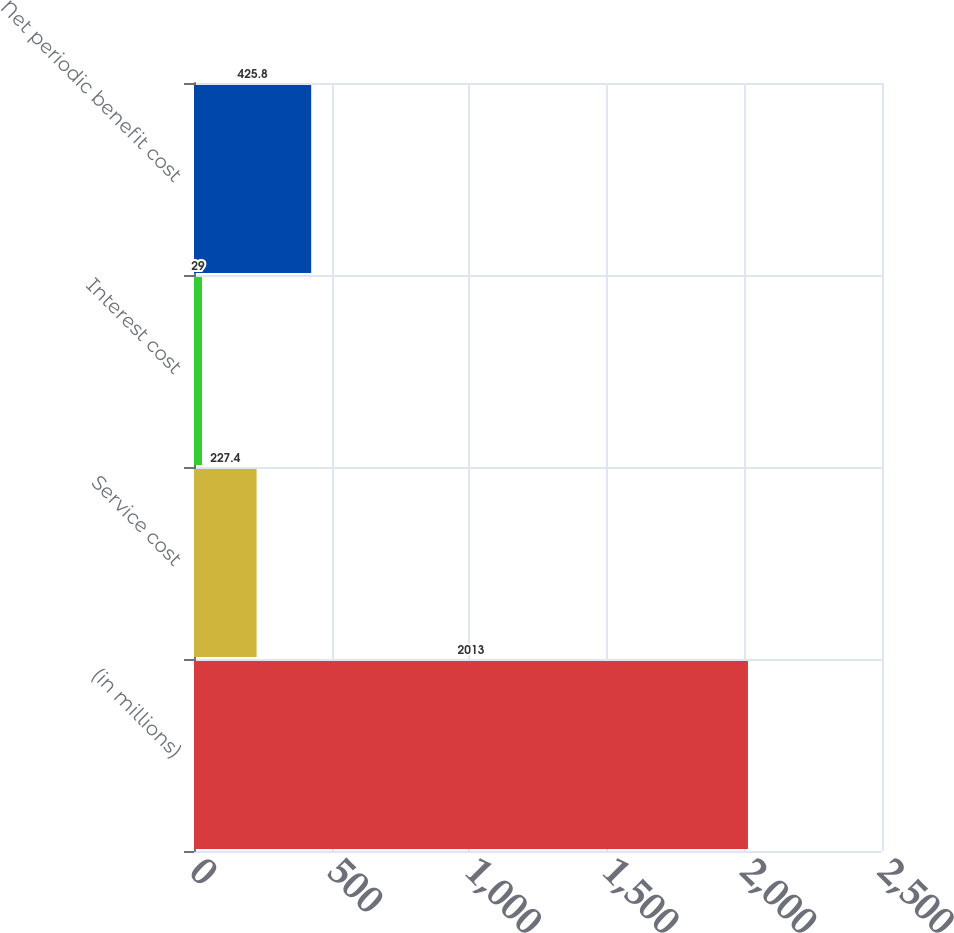Convert chart to OTSL. <chart><loc_0><loc_0><loc_500><loc_500><bar_chart><fcel>(in millions)<fcel>Service cost<fcel>Interest cost<fcel>Net periodic benefit cost<nl><fcel>2013<fcel>227.4<fcel>29<fcel>425.8<nl></chart> 